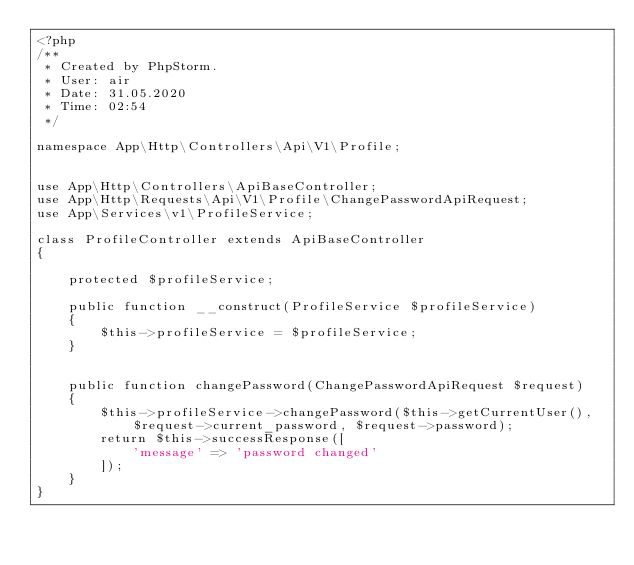Convert code to text. <code><loc_0><loc_0><loc_500><loc_500><_PHP_><?php
/**
 * Created by PhpStorm.
 * User: air
 * Date: 31.05.2020
 * Time: 02:54
 */

namespace App\Http\Controllers\Api\V1\Profile;


use App\Http\Controllers\ApiBaseController;
use App\Http\Requests\Api\V1\Profile\ChangePasswordApiRequest;
use App\Services\v1\ProfileService;

class ProfileController extends ApiBaseController
{

    protected $profileService;

    public function __construct(ProfileService $profileService)
    {
        $this->profileService = $profileService;
    }


    public function changePassword(ChangePasswordApiRequest $request)
    {
        $this->profileService->changePassword($this->getCurrentUser(), $request->current_password, $request->password);
        return $this->successResponse([
            'message' => 'password changed'
        ]);
    }
}</code> 